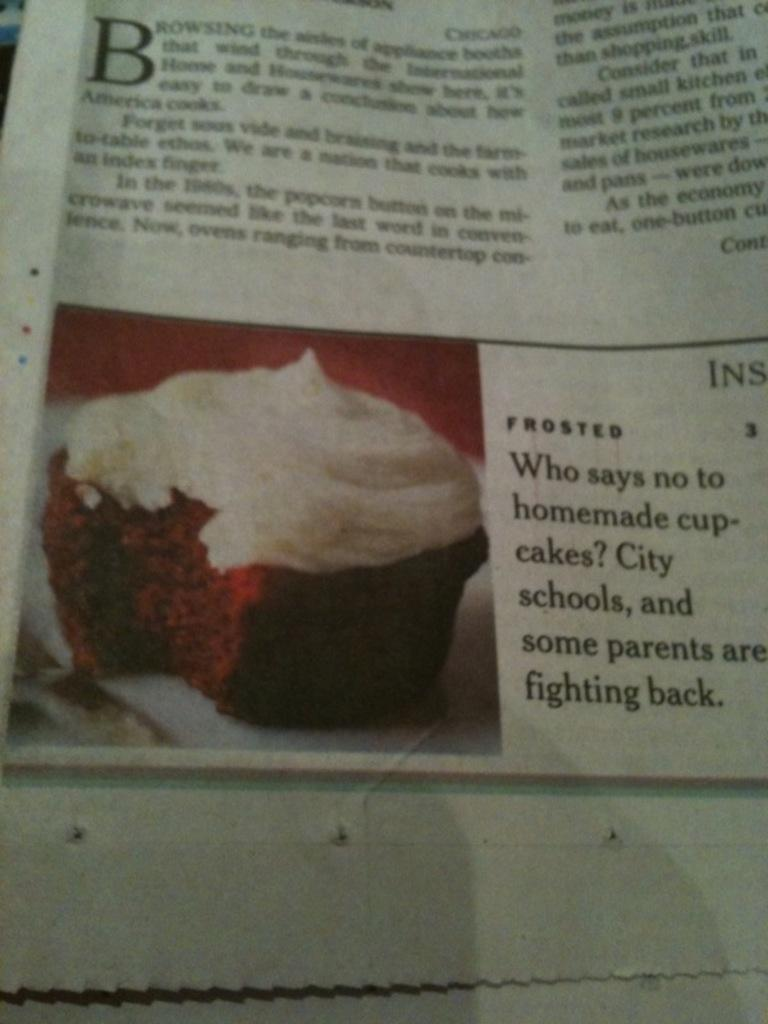<image>
Share a concise interpretation of the image provided. An article in the newspaper that says who says no to homemade cupcakes. 